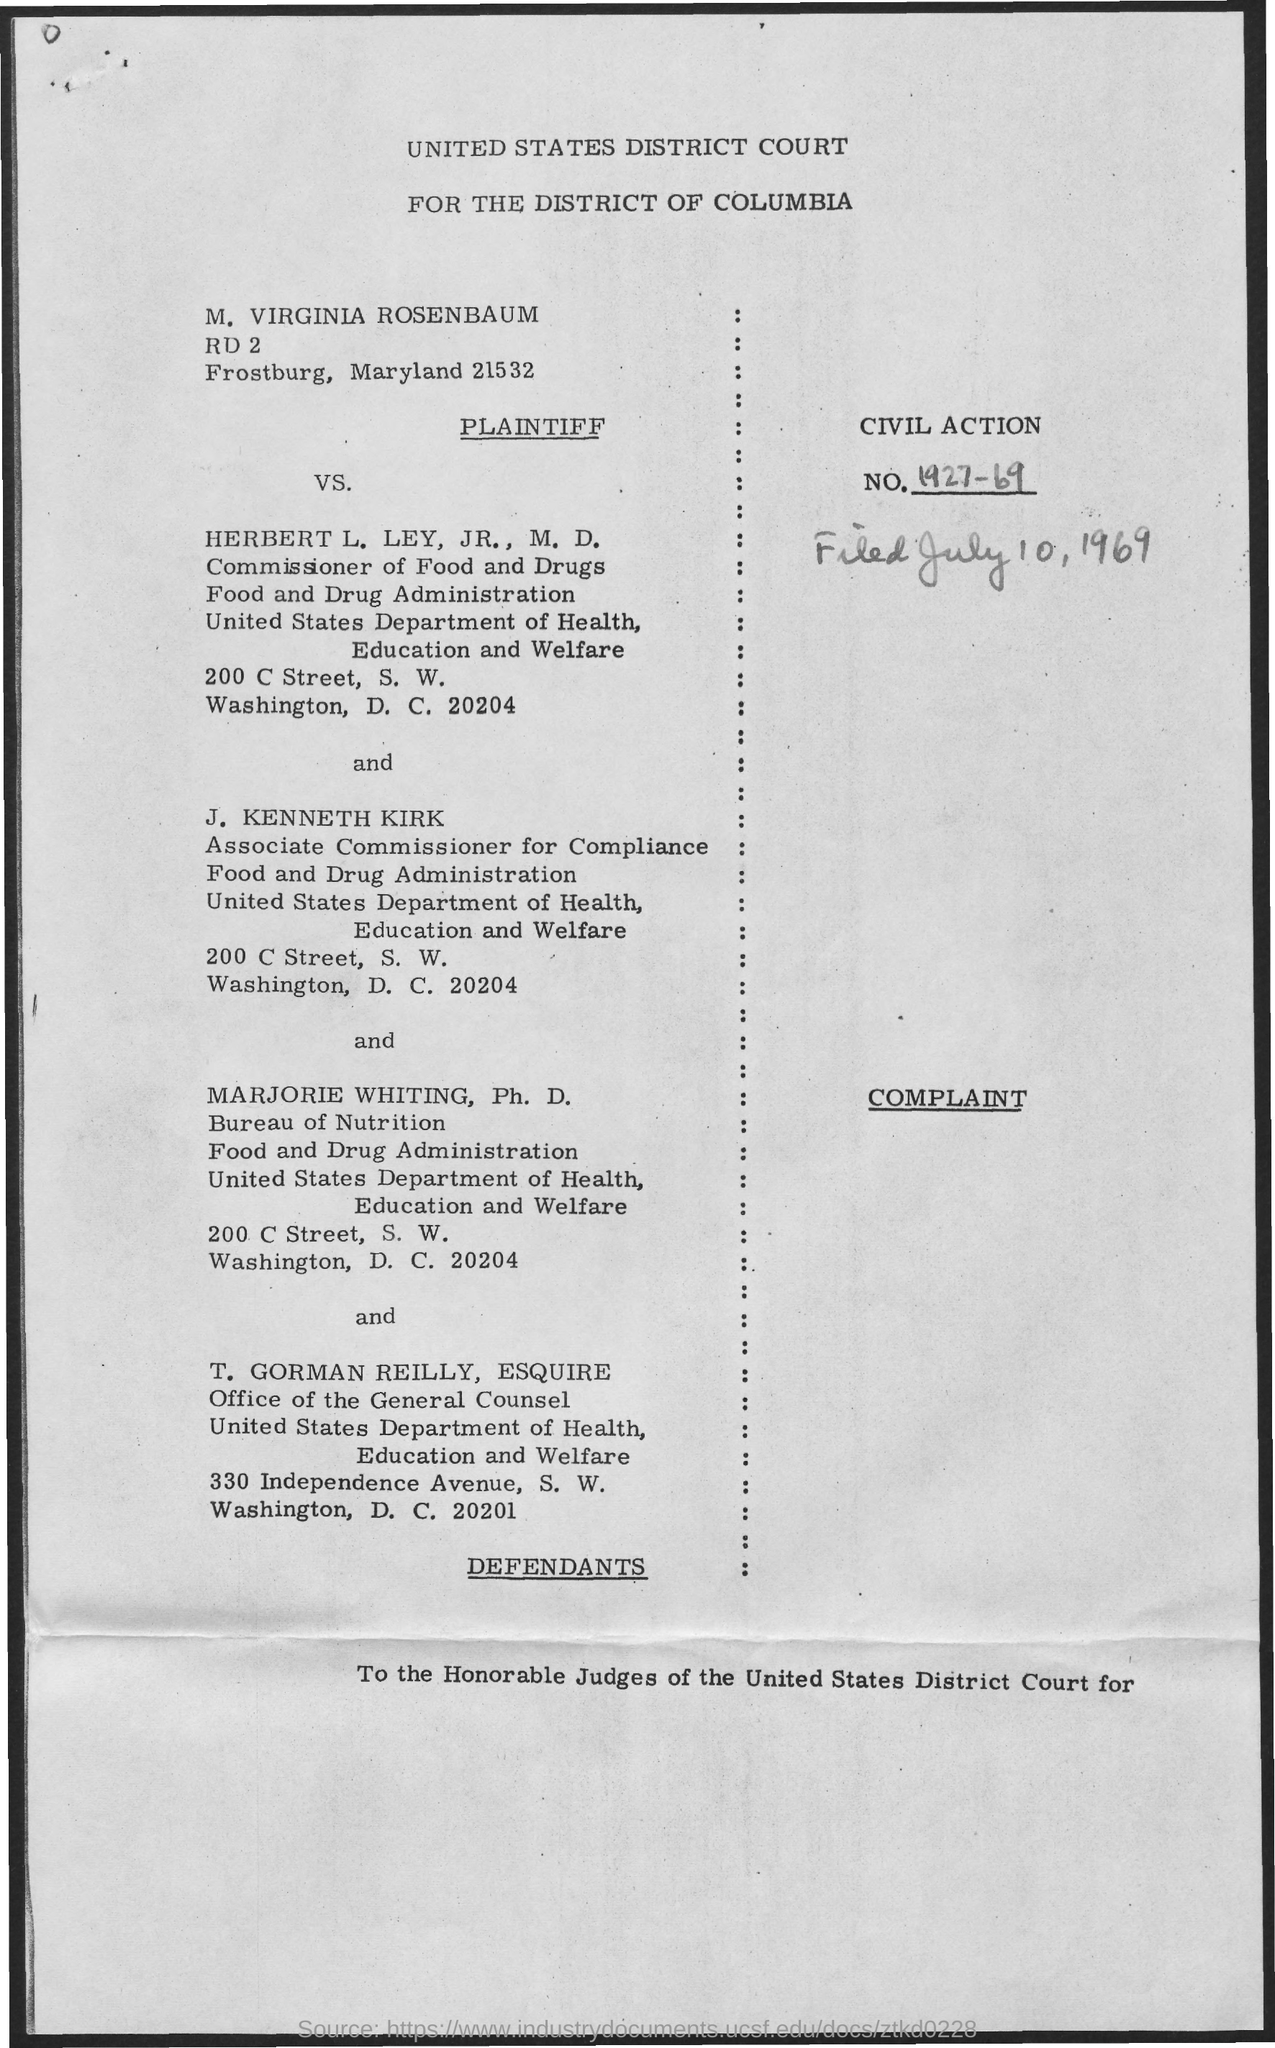What is the date mentioned ?
Provide a succinct answer. July 10 , 1969. What is the civil action  no ?
Provide a short and direct response. 1927-69. To which department T. Gorman Reilly  belongs to ?
Ensure brevity in your answer.  United states Department of health, education and welfare. 